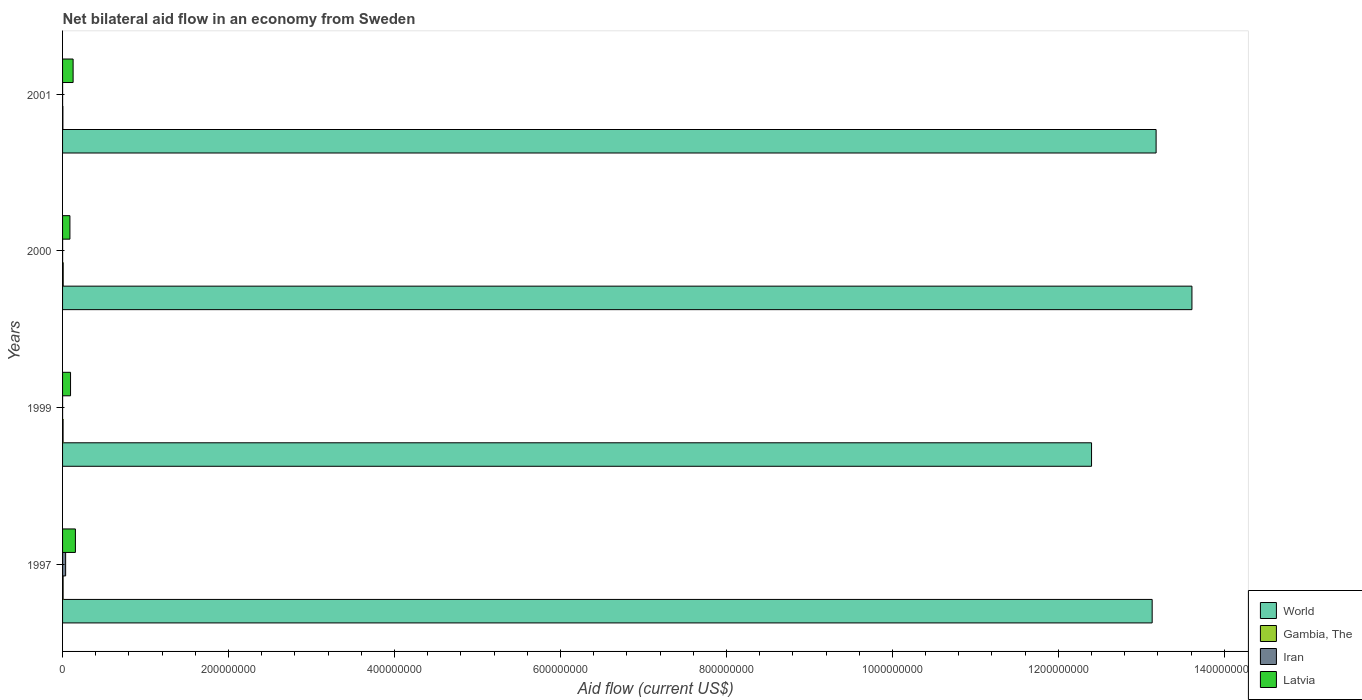How many groups of bars are there?
Your answer should be very brief. 4. Are the number of bars on each tick of the Y-axis equal?
Your answer should be very brief. Yes. In how many cases, is the number of bars for a given year not equal to the number of legend labels?
Give a very brief answer. 0. What is the net bilateral aid flow in World in 1999?
Your response must be concise. 1.24e+09. Across all years, what is the maximum net bilateral aid flow in Gambia, The?
Give a very brief answer. 7.40e+05. Across all years, what is the minimum net bilateral aid flow in World?
Keep it short and to the point. 1.24e+09. What is the total net bilateral aid flow in Gambia, The in the graph?
Your answer should be compact. 2.40e+06. What is the difference between the net bilateral aid flow in Latvia in 1997 and that in 2001?
Provide a short and direct response. 2.76e+06. What is the difference between the net bilateral aid flow in Gambia, The in 2000 and the net bilateral aid flow in Iran in 1999?
Offer a very short reply. 7.10e+05. What is the average net bilateral aid flow in World per year?
Keep it short and to the point. 1.31e+09. In the year 2000, what is the difference between the net bilateral aid flow in Latvia and net bilateral aid flow in World?
Offer a terse response. -1.35e+09. What is the ratio of the net bilateral aid flow in Latvia in 1999 to that in 2000?
Your response must be concise. 1.08. Is the net bilateral aid flow in Iran in 1997 less than that in 1999?
Make the answer very short. No. What is the difference between the highest and the second highest net bilateral aid flow in World?
Make the answer very short. 4.32e+07. What is the difference between the highest and the lowest net bilateral aid flow in Latvia?
Give a very brief answer. 6.61e+06. What does the 1st bar from the top in 1997 represents?
Your response must be concise. Latvia. Is it the case that in every year, the sum of the net bilateral aid flow in Latvia and net bilateral aid flow in Gambia, The is greater than the net bilateral aid flow in Iran?
Provide a short and direct response. Yes. How many bars are there?
Give a very brief answer. 16. What is the difference between two consecutive major ticks on the X-axis?
Your answer should be very brief. 2.00e+08. Are the values on the major ticks of X-axis written in scientific E-notation?
Your answer should be very brief. No. Does the graph contain grids?
Your answer should be compact. No. How many legend labels are there?
Keep it short and to the point. 4. How are the legend labels stacked?
Give a very brief answer. Vertical. What is the title of the graph?
Offer a terse response. Net bilateral aid flow in an economy from Sweden. Does "Lower middle income" appear as one of the legend labels in the graph?
Give a very brief answer. No. What is the Aid flow (current US$) in World in 1997?
Provide a succinct answer. 1.31e+09. What is the Aid flow (current US$) of Gambia, The in 1997?
Offer a terse response. 6.60e+05. What is the Aid flow (current US$) in Iran in 1997?
Provide a succinct answer. 3.71e+06. What is the Aid flow (current US$) of Latvia in 1997?
Your answer should be very brief. 1.55e+07. What is the Aid flow (current US$) in World in 1999?
Keep it short and to the point. 1.24e+09. What is the Aid flow (current US$) of Gambia, The in 1999?
Give a very brief answer. 6.10e+05. What is the Aid flow (current US$) of Latvia in 1999?
Provide a short and direct response. 9.61e+06. What is the Aid flow (current US$) of World in 2000?
Make the answer very short. 1.36e+09. What is the Aid flow (current US$) of Gambia, The in 2000?
Offer a terse response. 7.40e+05. What is the Aid flow (current US$) in Iran in 2000?
Your response must be concise. 6.00e+04. What is the Aid flow (current US$) of Latvia in 2000?
Offer a terse response. 8.86e+06. What is the Aid flow (current US$) in World in 2001?
Your response must be concise. 1.32e+09. What is the Aid flow (current US$) in Iran in 2001?
Provide a short and direct response. 3.00e+04. What is the Aid flow (current US$) of Latvia in 2001?
Your answer should be compact. 1.27e+07. Across all years, what is the maximum Aid flow (current US$) in World?
Provide a succinct answer. 1.36e+09. Across all years, what is the maximum Aid flow (current US$) in Gambia, The?
Offer a terse response. 7.40e+05. Across all years, what is the maximum Aid flow (current US$) of Iran?
Give a very brief answer. 3.71e+06. Across all years, what is the maximum Aid flow (current US$) of Latvia?
Ensure brevity in your answer.  1.55e+07. Across all years, what is the minimum Aid flow (current US$) of World?
Provide a short and direct response. 1.24e+09. Across all years, what is the minimum Aid flow (current US$) of Gambia, The?
Offer a very short reply. 3.90e+05. Across all years, what is the minimum Aid flow (current US$) of Latvia?
Give a very brief answer. 8.86e+06. What is the total Aid flow (current US$) of World in the graph?
Ensure brevity in your answer.  5.23e+09. What is the total Aid flow (current US$) in Gambia, The in the graph?
Give a very brief answer. 2.40e+06. What is the total Aid flow (current US$) of Iran in the graph?
Your answer should be very brief. 3.83e+06. What is the total Aid flow (current US$) in Latvia in the graph?
Provide a short and direct response. 4.66e+07. What is the difference between the Aid flow (current US$) in World in 1997 and that in 1999?
Offer a terse response. 7.30e+07. What is the difference between the Aid flow (current US$) in Iran in 1997 and that in 1999?
Provide a succinct answer. 3.68e+06. What is the difference between the Aid flow (current US$) of Latvia in 1997 and that in 1999?
Give a very brief answer. 5.86e+06. What is the difference between the Aid flow (current US$) in World in 1997 and that in 2000?
Provide a succinct answer. -4.79e+07. What is the difference between the Aid flow (current US$) in Gambia, The in 1997 and that in 2000?
Give a very brief answer. -8.00e+04. What is the difference between the Aid flow (current US$) of Iran in 1997 and that in 2000?
Provide a short and direct response. 3.65e+06. What is the difference between the Aid flow (current US$) of Latvia in 1997 and that in 2000?
Provide a succinct answer. 6.61e+06. What is the difference between the Aid flow (current US$) of World in 1997 and that in 2001?
Ensure brevity in your answer.  -4.75e+06. What is the difference between the Aid flow (current US$) in Iran in 1997 and that in 2001?
Your answer should be compact. 3.68e+06. What is the difference between the Aid flow (current US$) in Latvia in 1997 and that in 2001?
Provide a succinct answer. 2.76e+06. What is the difference between the Aid flow (current US$) in World in 1999 and that in 2000?
Keep it short and to the point. -1.21e+08. What is the difference between the Aid flow (current US$) of Gambia, The in 1999 and that in 2000?
Provide a succinct answer. -1.30e+05. What is the difference between the Aid flow (current US$) in Iran in 1999 and that in 2000?
Your answer should be compact. -3.00e+04. What is the difference between the Aid flow (current US$) of Latvia in 1999 and that in 2000?
Provide a succinct answer. 7.50e+05. What is the difference between the Aid flow (current US$) in World in 1999 and that in 2001?
Your answer should be very brief. -7.78e+07. What is the difference between the Aid flow (current US$) in Gambia, The in 1999 and that in 2001?
Offer a terse response. 2.20e+05. What is the difference between the Aid flow (current US$) of Latvia in 1999 and that in 2001?
Keep it short and to the point. -3.10e+06. What is the difference between the Aid flow (current US$) of World in 2000 and that in 2001?
Your answer should be very brief. 4.32e+07. What is the difference between the Aid flow (current US$) in Latvia in 2000 and that in 2001?
Give a very brief answer. -3.85e+06. What is the difference between the Aid flow (current US$) of World in 1997 and the Aid flow (current US$) of Gambia, The in 1999?
Provide a succinct answer. 1.31e+09. What is the difference between the Aid flow (current US$) in World in 1997 and the Aid flow (current US$) in Iran in 1999?
Your answer should be very brief. 1.31e+09. What is the difference between the Aid flow (current US$) of World in 1997 and the Aid flow (current US$) of Latvia in 1999?
Ensure brevity in your answer.  1.30e+09. What is the difference between the Aid flow (current US$) of Gambia, The in 1997 and the Aid flow (current US$) of Iran in 1999?
Offer a terse response. 6.30e+05. What is the difference between the Aid flow (current US$) of Gambia, The in 1997 and the Aid flow (current US$) of Latvia in 1999?
Your response must be concise. -8.95e+06. What is the difference between the Aid flow (current US$) of Iran in 1997 and the Aid flow (current US$) of Latvia in 1999?
Your answer should be compact. -5.90e+06. What is the difference between the Aid flow (current US$) in World in 1997 and the Aid flow (current US$) in Gambia, The in 2000?
Your answer should be compact. 1.31e+09. What is the difference between the Aid flow (current US$) in World in 1997 and the Aid flow (current US$) in Iran in 2000?
Make the answer very short. 1.31e+09. What is the difference between the Aid flow (current US$) in World in 1997 and the Aid flow (current US$) in Latvia in 2000?
Make the answer very short. 1.30e+09. What is the difference between the Aid flow (current US$) of Gambia, The in 1997 and the Aid flow (current US$) of Iran in 2000?
Keep it short and to the point. 6.00e+05. What is the difference between the Aid flow (current US$) in Gambia, The in 1997 and the Aid flow (current US$) in Latvia in 2000?
Offer a very short reply. -8.20e+06. What is the difference between the Aid flow (current US$) in Iran in 1997 and the Aid flow (current US$) in Latvia in 2000?
Offer a very short reply. -5.15e+06. What is the difference between the Aid flow (current US$) of World in 1997 and the Aid flow (current US$) of Gambia, The in 2001?
Your answer should be very brief. 1.31e+09. What is the difference between the Aid flow (current US$) of World in 1997 and the Aid flow (current US$) of Iran in 2001?
Your answer should be very brief. 1.31e+09. What is the difference between the Aid flow (current US$) of World in 1997 and the Aid flow (current US$) of Latvia in 2001?
Provide a short and direct response. 1.30e+09. What is the difference between the Aid flow (current US$) of Gambia, The in 1997 and the Aid flow (current US$) of Iran in 2001?
Your response must be concise. 6.30e+05. What is the difference between the Aid flow (current US$) of Gambia, The in 1997 and the Aid flow (current US$) of Latvia in 2001?
Your answer should be very brief. -1.20e+07. What is the difference between the Aid flow (current US$) in Iran in 1997 and the Aid flow (current US$) in Latvia in 2001?
Provide a succinct answer. -9.00e+06. What is the difference between the Aid flow (current US$) in World in 1999 and the Aid flow (current US$) in Gambia, The in 2000?
Provide a succinct answer. 1.24e+09. What is the difference between the Aid flow (current US$) in World in 1999 and the Aid flow (current US$) in Iran in 2000?
Provide a succinct answer. 1.24e+09. What is the difference between the Aid flow (current US$) in World in 1999 and the Aid flow (current US$) in Latvia in 2000?
Your answer should be very brief. 1.23e+09. What is the difference between the Aid flow (current US$) of Gambia, The in 1999 and the Aid flow (current US$) of Iran in 2000?
Your answer should be very brief. 5.50e+05. What is the difference between the Aid flow (current US$) of Gambia, The in 1999 and the Aid flow (current US$) of Latvia in 2000?
Provide a succinct answer. -8.25e+06. What is the difference between the Aid flow (current US$) in Iran in 1999 and the Aid flow (current US$) in Latvia in 2000?
Provide a succinct answer. -8.83e+06. What is the difference between the Aid flow (current US$) of World in 1999 and the Aid flow (current US$) of Gambia, The in 2001?
Provide a succinct answer. 1.24e+09. What is the difference between the Aid flow (current US$) of World in 1999 and the Aid flow (current US$) of Iran in 2001?
Offer a terse response. 1.24e+09. What is the difference between the Aid flow (current US$) in World in 1999 and the Aid flow (current US$) in Latvia in 2001?
Offer a very short reply. 1.23e+09. What is the difference between the Aid flow (current US$) of Gambia, The in 1999 and the Aid flow (current US$) of Iran in 2001?
Provide a short and direct response. 5.80e+05. What is the difference between the Aid flow (current US$) in Gambia, The in 1999 and the Aid flow (current US$) in Latvia in 2001?
Keep it short and to the point. -1.21e+07. What is the difference between the Aid flow (current US$) in Iran in 1999 and the Aid flow (current US$) in Latvia in 2001?
Provide a succinct answer. -1.27e+07. What is the difference between the Aid flow (current US$) of World in 2000 and the Aid flow (current US$) of Gambia, The in 2001?
Provide a succinct answer. 1.36e+09. What is the difference between the Aid flow (current US$) of World in 2000 and the Aid flow (current US$) of Iran in 2001?
Your answer should be compact. 1.36e+09. What is the difference between the Aid flow (current US$) of World in 2000 and the Aid flow (current US$) of Latvia in 2001?
Your answer should be very brief. 1.35e+09. What is the difference between the Aid flow (current US$) of Gambia, The in 2000 and the Aid flow (current US$) of Iran in 2001?
Provide a short and direct response. 7.10e+05. What is the difference between the Aid flow (current US$) in Gambia, The in 2000 and the Aid flow (current US$) in Latvia in 2001?
Make the answer very short. -1.20e+07. What is the difference between the Aid flow (current US$) of Iran in 2000 and the Aid flow (current US$) of Latvia in 2001?
Offer a terse response. -1.26e+07. What is the average Aid flow (current US$) of World per year?
Ensure brevity in your answer.  1.31e+09. What is the average Aid flow (current US$) in Iran per year?
Offer a very short reply. 9.58e+05. What is the average Aid flow (current US$) of Latvia per year?
Offer a terse response. 1.17e+07. In the year 1997, what is the difference between the Aid flow (current US$) in World and Aid flow (current US$) in Gambia, The?
Offer a terse response. 1.31e+09. In the year 1997, what is the difference between the Aid flow (current US$) of World and Aid flow (current US$) of Iran?
Give a very brief answer. 1.31e+09. In the year 1997, what is the difference between the Aid flow (current US$) in World and Aid flow (current US$) in Latvia?
Your answer should be very brief. 1.30e+09. In the year 1997, what is the difference between the Aid flow (current US$) in Gambia, The and Aid flow (current US$) in Iran?
Provide a succinct answer. -3.05e+06. In the year 1997, what is the difference between the Aid flow (current US$) of Gambia, The and Aid flow (current US$) of Latvia?
Your answer should be very brief. -1.48e+07. In the year 1997, what is the difference between the Aid flow (current US$) of Iran and Aid flow (current US$) of Latvia?
Your answer should be compact. -1.18e+07. In the year 1999, what is the difference between the Aid flow (current US$) of World and Aid flow (current US$) of Gambia, The?
Provide a short and direct response. 1.24e+09. In the year 1999, what is the difference between the Aid flow (current US$) in World and Aid flow (current US$) in Iran?
Ensure brevity in your answer.  1.24e+09. In the year 1999, what is the difference between the Aid flow (current US$) in World and Aid flow (current US$) in Latvia?
Provide a short and direct response. 1.23e+09. In the year 1999, what is the difference between the Aid flow (current US$) in Gambia, The and Aid flow (current US$) in Iran?
Provide a short and direct response. 5.80e+05. In the year 1999, what is the difference between the Aid flow (current US$) of Gambia, The and Aid flow (current US$) of Latvia?
Make the answer very short. -9.00e+06. In the year 1999, what is the difference between the Aid flow (current US$) in Iran and Aid flow (current US$) in Latvia?
Offer a terse response. -9.58e+06. In the year 2000, what is the difference between the Aid flow (current US$) in World and Aid flow (current US$) in Gambia, The?
Your answer should be compact. 1.36e+09. In the year 2000, what is the difference between the Aid flow (current US$) in World and Aid flow (current US$) in Iran?
Provide a succinct answer. 1.36e+09. In the year 2000, what is the difference between the Aid flow (current US$) in World and Aid flow (current US$) in Latvia?
Provide a succinct answer. 1.35e+09. In the year 2000, what is the difference between the Aid flow (current US$) in Gambia, The and Aid flow (current US$) in Iran?
Keep it short and to the point. 6.80e+05. In the year 2000, what is the difference between the Aid flow (current US$) of Gambia, The and Aid flow (current US$) of Latvia?
Your response must be concise. -8.12e+06. In the year 2000, what is the difference between the Aid flow (current US$) in Iran and Aid flow (current US$) in Latvia?
Give a very brief answer. -8.80e+06. In the year 2001, what is the difference between the Aid flow (current US$) of World and Aid flow (current US$) of Gambia, The?
Give a very brief answer. 1.32e+09. In the year 2001, what is the difference between the Aid flow (current US$) in World and Aid flow (current US$) in Iran?
Ensure brevity in your answer.  1.32e+09. In the year 2001, what is the difference between the Aid flow (current US$) of World and Aid flow (current US$) of Latvia?
Your answer should be compact. 1.31e+09. In the year 2001, what is the difference between the Aid flow (current US$) of Gambia, The and Aid flow (current US$) of Latvia?
Keep it short and to the point. -1.23e+07. In the year 2001, what is the difference between the Aid flow (current US$) of Iran and Aid flow (current US$) of Latvia?
Your response must be concise. -1.27e+07. What is the ratio of the Aid flow (current US$) of World in 1997 to that in 1999?
Give a very brief answer. 1.06. What is the ratio of the Aid flow (current US$) in Gambia, The in 1997 to that in 1999?
Give a very brief answer. 1.08. What is the ratio of the Aid flow (current US$) of Iran in 1997 to that in 1999?
Your answer should be very brief. 123.67. What is the ratio of the Aid flow (current US$) in Latvia in 1997 to that in 1999?
Provide a succinct answer. 1.61. What is the ratio of the Aid flow (current US$) of World in 1997 to that in 2000?
Make the answer very short. 0.96. What is the ratio of the Aid flow (current US$) in Gambia, The in 1997 to that in 2000?
Your answer should be very brief. 0.89. What is the ratio of the Aid flow (current US$) of Iran in 1997 to that in 2000?
Offer a terse response. 61.83. What is the ratio of the Aid flow (current US$) in Latvia in 1997 to that in 2000?
Keep it short and to the point. 1.75. What is the ratio of the Aid flow (current US$) in Gambia, The in 1997 to that in 2001?
Keep it short and to the point. 1.69. What is the ratio of the Aid flow (current US$) in Iran in 1997 to that in 2001?
Ensure brevity in your answer.  123.67. What is the ratio of the Aid flow (current US$) of Latvia in 1997 to that in 2001?
Offer a terse response. 1.22. What is the ratio of the Aid flow (current US$) in World in 1999 to that in 2000?
Offer a very short reply. 0.91. What is the ratio of the Aid flow (current US$) of Gambia, The in 1999 to that in 2000?
Your response must be concise. 0.82. What is the ratio of the Aid flow (current US$) of Iran in 1999 to that in 2000?
Offer a terse response. 0.5. What is the ratio of the Aid flow (current US$) in Latvia in 1999 to that in 2000?
Ensure brevity in your answer.  1.08. What is the ratio of the Aid flow (current US$) of World in 1999 to that in 2001?
Give a very brief answer. 0.94. What is the ratio of the Aid flow (current US$) in Gambia, The in 1999 to that in 2001?
Provide a succinct answer. 1.56. What is the ratio of the Aid flow (current US$) in Iran in 1999 to that in 2001?
Make the answer very short. 1. What is the ratio of the Aid flow (current US$) of Latvia in 1999 to that in 2001?
Provide a short and direct response. 0.76. What is the ratio of the Aid flow (current US$) in World in 2000 to that in 2001?
Make the answer very short. 1.03. What is the ratio of the Aid flow (current US$) of Gambia, The in 2000 to that in 2001?
Make the answer very short. 1.9. What is the ratio of the Aid flow (current US$) of Latvia in 2000 to that in 2001?
Provide a short and direct response. 0.7. What is the difference between the highest and the second highest Aid flow (current US$) of World?
Give a very brief answer. 4.32e+07. What is the difference between the highest and the second highest Aid flow (current US$) of Iran?
Your response must be concise. 3.65e+06. What is the difference between the highest and the second highest Aid flow (current US$) in Latvia?
Make the answer very short. 2.76e+06. What is the difference between the highest and the lowest Aid flow (current US$) in World?
Ensure brevity in your answer.  1.21e+08. What is the difference between the highest and the lowest Aid flow (current US$) in Iran?
Offer a very short reply. 3.68e+06. What is the difference between the highest and the lowest Aid flow (current US$) of Latvia?
Give a very brief answer. 6.61e+06. 